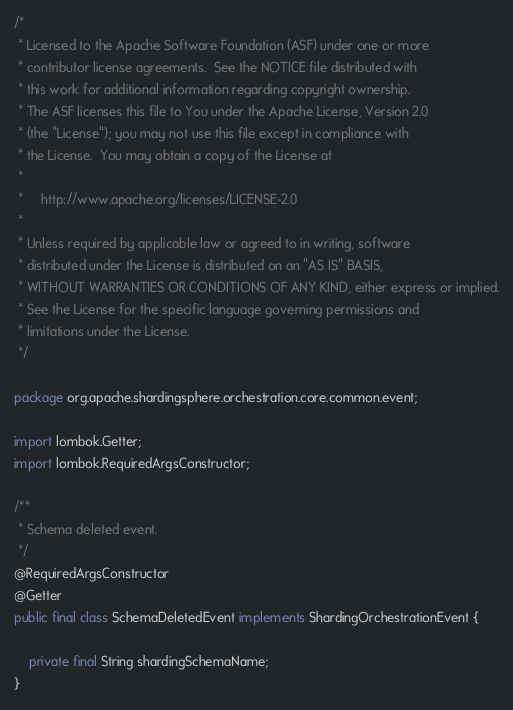<code> <loc_0><loc_0><loc_500><loc_500><_Java_>/*
 * Licensed to the Apache Software Foundation (ASF) under one or more
 * contributor license agreements.  See the NOTICE file distributed with
 * this work for additional information regarding copyright ownership.
 * The ASF licenses this file to You under the Apache License, Version 2.0
 * (the "License"); you may not use this file except in compliance with
 * the License.  You may obtain a copy of the License at
 *
 *     http://www.apache.org/licenses/LICENSE-2.0
 *
 * Unless required by applicable law or agreed to in writing, software
 * distributed under the License is distributed on an "AS IS" BASIS,
 * WITHOUT WARRANTIES OR CONDITIONS OF ANY KIND, either express or implied.
 * See the License for the specific language governing permissions and
 * limitations under the License.
 */

package org.apache.shardingsphere.orchestration.core.common.event;

import lombok.Getter;
import lombok.RequiredArgsConstructor;

/**
 * Schema deleted event.
 */
@RequiredArgsConstructor
@Getter
public final class SchemaDeletedEvent implements ShardingOrchestrationEvent {

    private final String shardingSchemaName;
}
</code> 